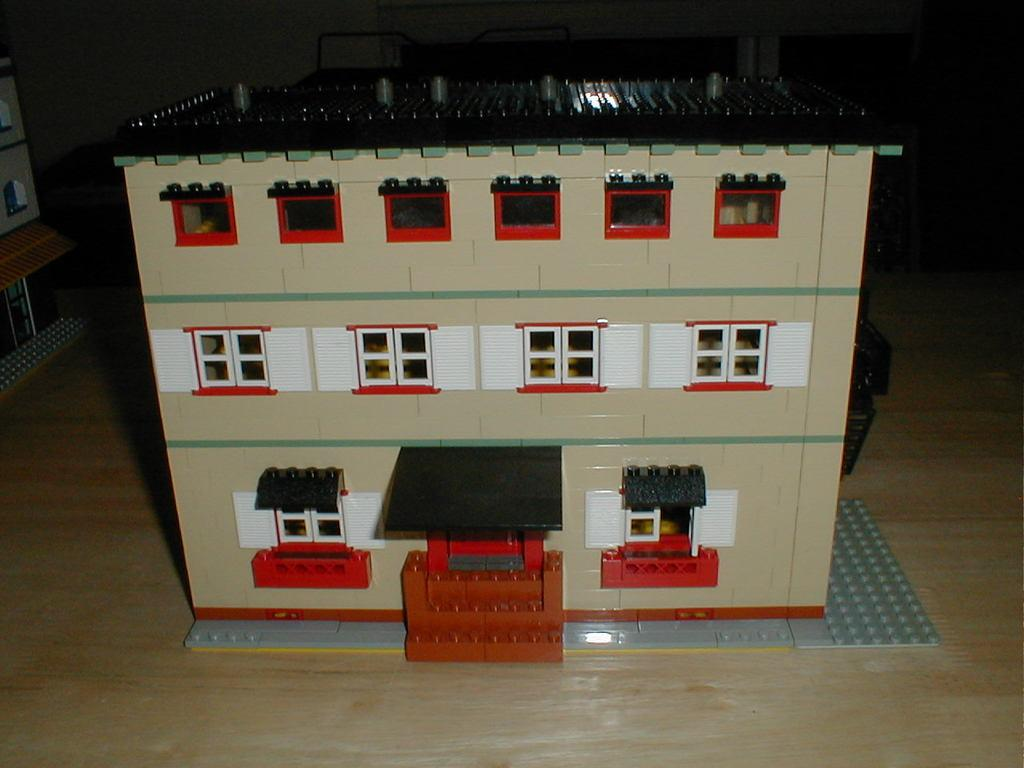What type of structure is present in the image? There is a house in the image. What feature can be seen on the house? The house has windows. How is the house constructed? The house is built with Lego blocks. Where are the Lego blocks placed? The Lego blocks are placed on the floor. What else can be seen in the background of the image? There is another building visible in the background of the image. How many clocks are hanging on the walls of the house in the image? There are no clocks visible in the image; the house is built with Lego blocks and does not have walls or any items hanging on them. 